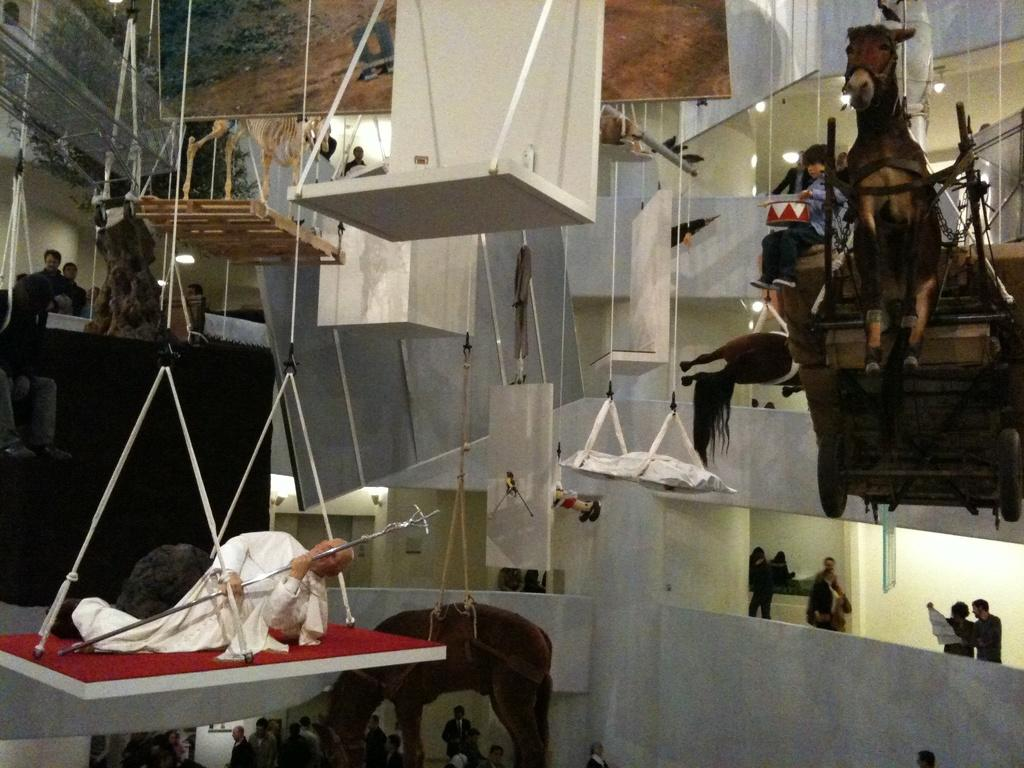Who or what can be seen in the image? There are people in the image. What unusual object is hanging from the roof? There is a horse hanging from the roof. How is the horse attached to the roof? The horse is hanged to the roof. What else can be seen in the image besides the people and the horse? There are other people and things visible in the image. What type of game is being played by the people in the image? There is no game being played in the image; the focus is on the horse hanging from the roof. 